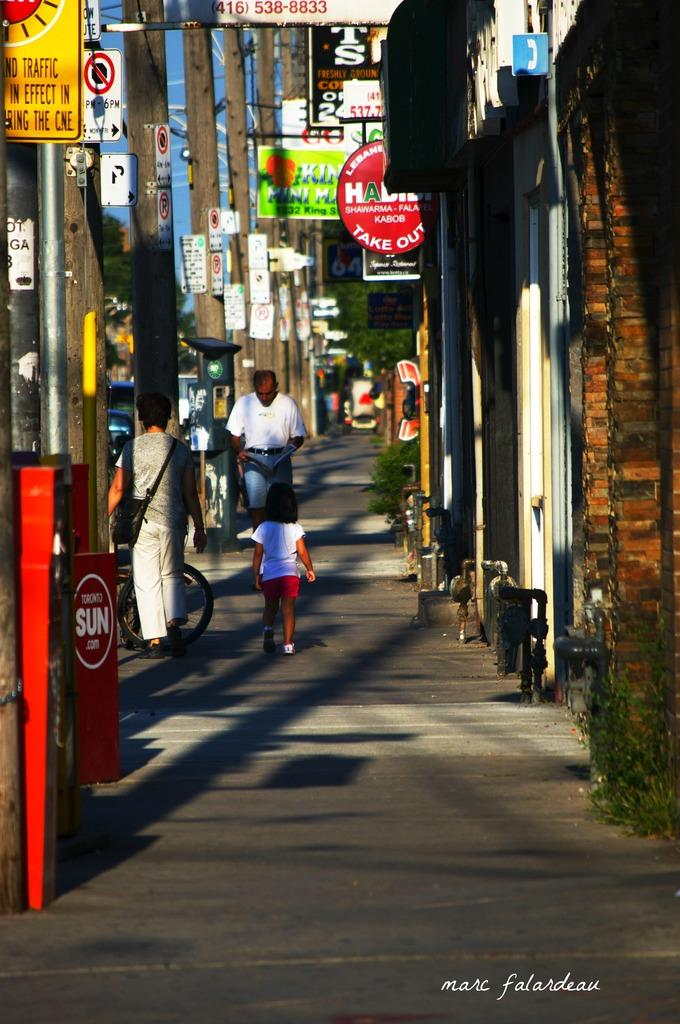Provide a one-sentence caption for the provided image. A street with a newspaper box for the Toronto Sun on the side. 